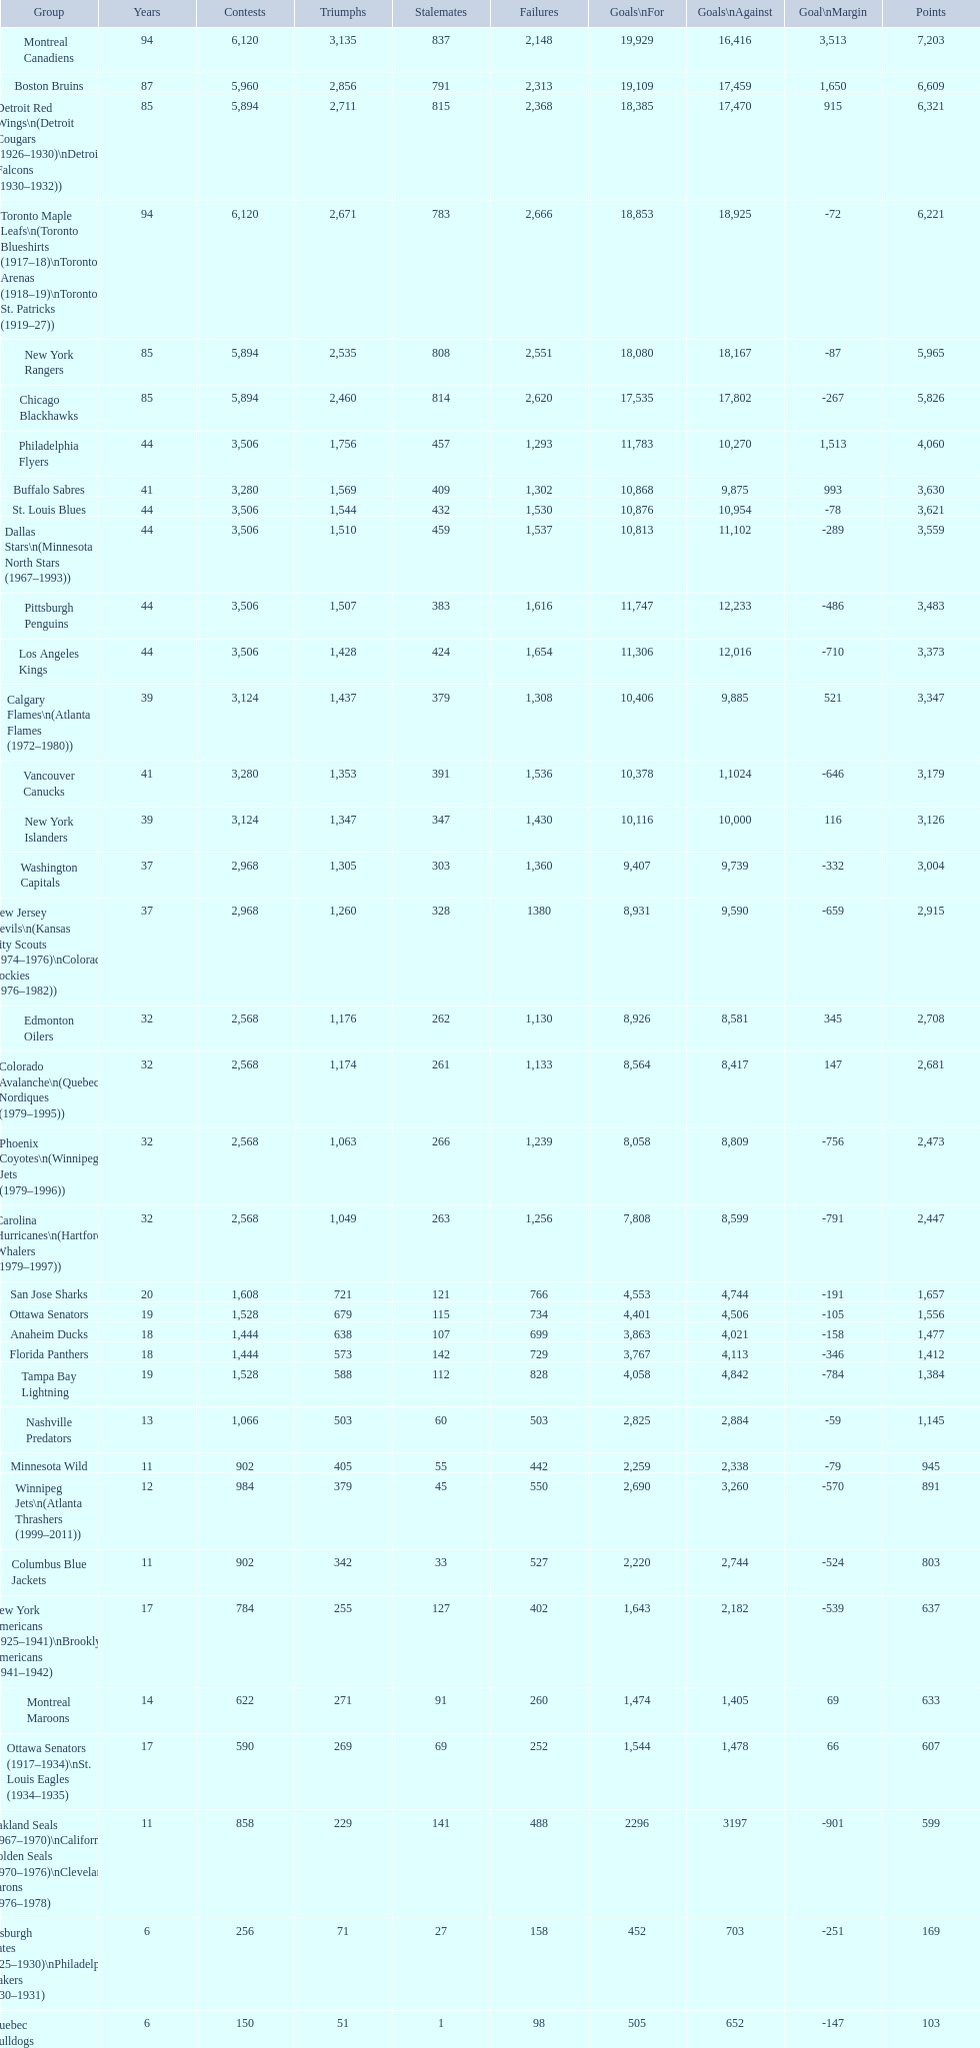I'm looking to parse the entire table for insights. Could you assist me with that? {'header': ['Group', 'Years', 'Contests', 'Triumphs', 'Stalemates', 'Failures', 'Goals\\nFor', 'Goals\\nAgainst', 'Goal\\nMargin', 'Points'], 'rows': [['Montreal Canadiens', '94', '6,120', '3,135', '837', '2,148', '19,929', '16,416', '3,513', '7,203'], ['Boston Bruins', '87', '5,960', '2,856', '791', '2,313', '19,109', '17,459', '1,650', '6,609'], ['Detroit Red Wings\\n(Detroit Cougars (1926–1930)\\nDetroit Falcons (1930–1932))', '85', '5,894', '2,711', '815', '2,368', '18,385', '17,470', '915', '6,321'], ['Toronto Maple Leafs\\n(Toronto Blueshirts (1917–18)\\nToronto Arenas (1918–19)\\nToronto St. Patricks (1919–27))', '94', '6,120', '2,671', '783', '2,666', '18,853', '18,925', '-72', '6,221'], ['New York Rangers', '85', '5,894', '2,535', '808', '2,551', '18,080', '18,167', '-87', '5,965'], ['Chicago Blackhawks', '85', '5,894', '2,460', '814', '2,620', '17,535', '17,802', '-267', '5,826'], ['Philadelphia Flyers', '44', '3,506', '1,756', '457', '1,293', '11,783', '10,270', '1,513', '4,060'], ['Buffalo Sabres', '41', '3,280', '1,569', '409', '1,302', '10,868', '9,875', '993', '3,630'], ['St. Louis Blues', '44', '3,506', '1,544', '432', '1,530', '10,876', '10,954', '-78', '3,621'], ['Dallas Stars\\n(Minnesota North Stars (1967–1993))', '44', '3,506', '1,510', '459', '1,537', '10,813', '11,102', '-289', '3,559'], ['Pittsburgh Penguins', '44', '3,506', '1,507', '383', '1,616', '11,747', '12,233', '-486', '3,483'], ['Los Angeles Kings', '44', '3,506', '1,428', '424', '1,654', '11,306', '12,016', '-710', '3,373'], ['Calgary Flames\\n(Atlanta Flames (1972–1980))', '39', '3,124', '1,437', '379', '1,308', '10,406', '9,885', '521', '3,347'], ['Vancouver Canucks', '41', '3,280', '1,353', '391', '1,536', '10,378', '1,1024', '-646', '3,179'], ['New York Islanders', '39', '3,124', '1,347', '347', '1,430', '10,116', '10,000', '116', '3,126'], ['Washington Capitals', '37', '2,968', '1,305', '303', '1,360', '9,407', '9,739', '-332', '3,004'], ['New Jersey Devils\\n(Kansas City Scouts (1974–1976)\\nColorado Rockies (1976–1982))', '37', '2,968', '1,260', '328', '1380', '8,931', '9,590', '-659', '2,915'], ['Edmonton Oilers', '32', '2,568', '1,176', '262', '1,130', '8,926', '8,581', '345', '2,708'], ['Colorado Avalanche\\n(Quebec Nordiques (1979–1995))', '32', '2,568', '1,174', '261', '1,133', '8,564', '8,417', '147', '2,681'], ['Phoenix Coyotes\\n(Winnipeg Jets (1979–1996))', '32', '2,568', '1,063', '266', '1,239', '8,058', '8,809', '-756', '2,473'], ['Carolina Hurricanes\\n(Hartford Whalers (1979–1997))', '32', '2,568', '1,049', '263', '1,256', '7,808', '8,599', '-791', '2,447'], ['San Jose Sharks', '20', '1,608', '721', '121', '766', '4,553', '4,744', '-191', '1,657'], ['Ottawa Senators', '19', '1,528', '679', '115', '734', '4,401', '4,506', '-105', '1,556'], ['Anaheim Ducks', '18', '1,444', '638', '107', '699', '3,863', '4,021', '-158', '1,477'], ['Florida Panthers', '18', '1,444', '573', '142', '729', '3,767', '4,113', '-346', '1,412'], ['Tampa Bay Lightning', '19', '1,528', '588', '112', '828', '4,058', '4,842', '-784', '1,384'], ['Nashville Predators', '13', '1,066', '503', '60', '503', '2,825', '2,884', '-59', '1,145'], ['Minnesota Wild', '11', '902', '405', '55', '442', '2,259', '2,338', '-79', '945'], ['Winnipeg Jets\\n(Atlanta Thrashers (1999–2011))', '12', '984', '379', '45', '550', '2,690', '3,260', '-570', '891'], ['Columbus Blue Jackets', '11', '902', '342', '33', '527', '2,220', '2,744', '-524', '803'], ['New York Americans (1925–1941)\\nBrooklyn Americans (1941–1942)', '17', '784', '255', '127', '402', '1,643', '2,182', '-539', '637'], ['Montreal Maroons', '14', '622', '271', '91', '260', '1,474', '1,405', '69', '633'], ['Ottawa Senators (1917–1934)\\nSt. Louis Eagles (1934–1935)', '17', '590', '269', '69', '252', '1,544', '1,478', '66', '607'], ['Oakland Seals (1967–1970)\\nCalifornia Golden Seals (1970–1976)\\nCleveland Barons (1976–1978)', '11', '858', '229', '141', '488', '2296', '3197', '-901', '599'], ['Pittsburgh Pirates (1925–1930)\\nPhiladelphia Quakers (1930–1931)', '6', '256', '71', '27', '158', '452', '703', '-251', '169'], ['Quebec Bulldogs (1919–1920)\\nHamilton Tigers (1920–1925)', '6', '150', '51', '1', '98', '505', '652', '-147', '103'], ['Montreal Wanderers', '1', '6', '1', '0', '5', '17', '35', '-18', '2']]} Which team was last in terms of points up until this point? Montreal Wanderers. 